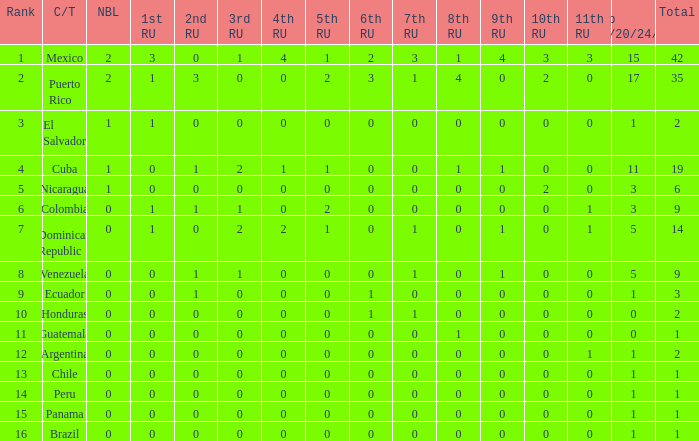What is the average total of the country with a 4th runner-up of 0 and a Nuestra Bellaza Latina less than 0? None. 